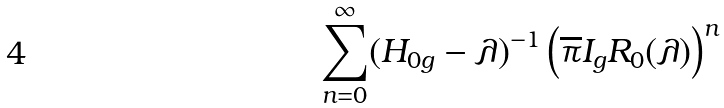Convert formula to latex. <formula><loc_0><loc_0><loc_500><loc_500>\sum _ { n = 0 } ^ { \infty } ( H _ { 0 g } - \lambda ) ^ { - 1 } \left ( \overline { \pi } I _ { g } R _ { 0 } ( \lambda ) \right ) ^ { n }</formula> 